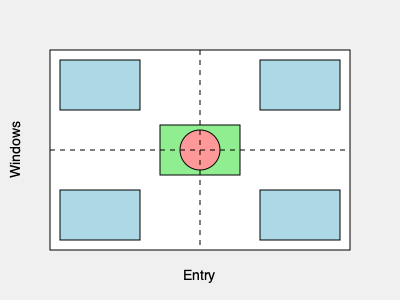In the given floor plan of a senior center lounge, which furniture arrangement would best promote accessibility and social interaction for seniors? To determine the best furniture arrangement for accessibility and social interaction in a senior center lounge, we need to consider several factors:

1. Clear pathways: The center of the room should remain open to allow easy movement for seniors with mobility aids.

2. Seating options: Chairs should be placed around the room to provide various seating choices.

3. Social interaction: Furniture should be arranged to encourage conversation and group activities.

4. Natural light: Seating near windows can benefit seniors' well-being.

5. Central focus: A common area or table in the center can serve as a gathering point.

Analyzing the floor plan:

- The dashed lines indicate the center of the room, which should be kept clear for easy navigation.
- The blue rectangles represent chairs or small sofas.
- The green rectangle in the center represents a table.
- The pink circle in the center of the table could be a centerpiece or a shared item.
- The "Entry" label at the bottom indicates the entrance to the room.
- The "Windows" label on the left suggests natural light coming from that side.

This arrangement satisfies our requirements because:

1. The central pathway is clear, allowing easy movement throughout the room.
2. Chairs are placed around the perimeter, providing various seating options.
3. The chairs are arranged in small groups, encouraging social interaction.
4. Some chairs are placed near the windows, allowing seniors to enjoy natural light.
5. The central table serves as a focal point for group activities and conversations.

Therefore, this furniture arrangement is optimal for promoting accessibility and social interaction in the senior center lounge.
Answer: The given arrangement 